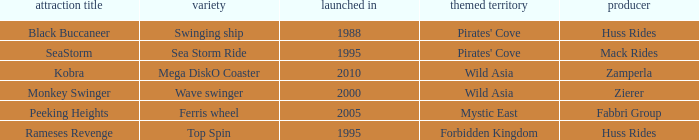What ride was manufactured by Zierer? Monkey Swinger. 